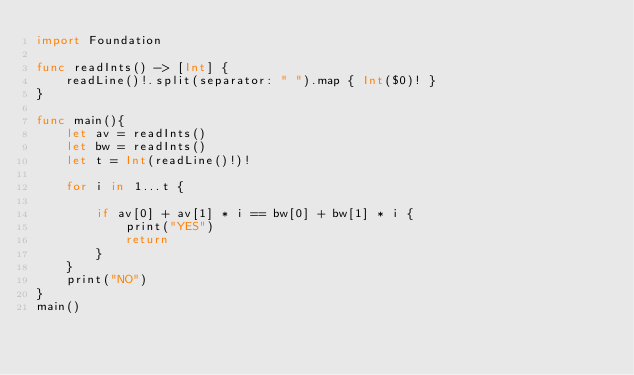Convert code to text. <code><loc_0><loc_0><loc_500><loc_500><_Swift_>import Foundation

func readInts() -> [Int] {
    readLine()!.split(separator: " ").map { Int($0)! }
}

func main(){
    let av = readInts()
    let bw = readInts()
    let t = Int(readLine()!)!
        
    for i in 1...t {
        
        if av[0] + av[1] * i == bw[0] + bw[1] * i {
            print("YES")
            return
        }
    }
    print("NO")
}
main()
</code> 